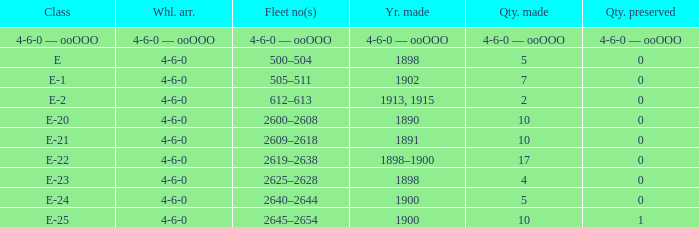What is the wheel arrangement with 1 quantity preserved? 4-6-0. 